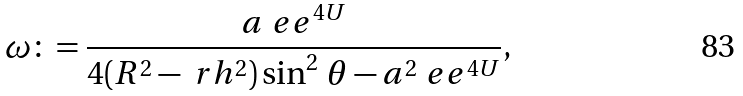<formula> <loc_0><loc_0><loc_500><loc_500>\omega \colon = \frac { a \ e e ^ { 4 U } } { 4 ( R ^ { 2 } - \ r h ^ { 2 } ) \sin ^ { 2 } \, \theta - a ^ { 2 } \ e e ^ { 4 U } } ,</formula> 